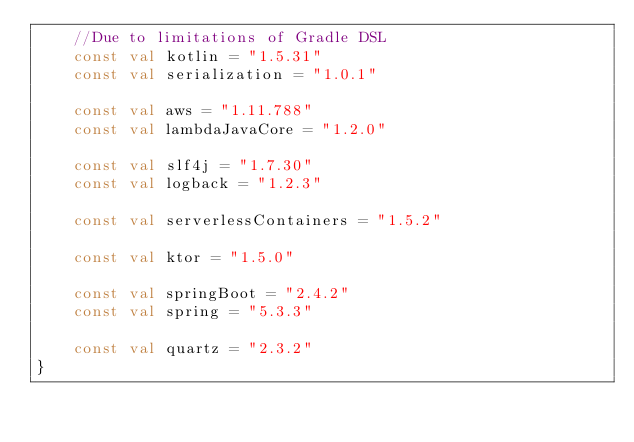<code> <loc_0><loc_0><loc_500><loc_500><_Kotlin_>    //Due to limitations of Gradle DSL
    const val kotlin = "1.5.31"
    const val serialization = "1.0.1"

    const val aws = "1.11.788"
    const val lambdaJavaCore = "1.2.0"

    const val slf4j = "1.7.30"
    const val logback = "1.2.3"

    const val serverlessContainers = "1.5.2"

    const val ktor = "1.5.0"

    const val springBoot = "2.4.2"
    const val spring = "5.3.3"

    const val quartz = "2.3.2"
}
</code> 